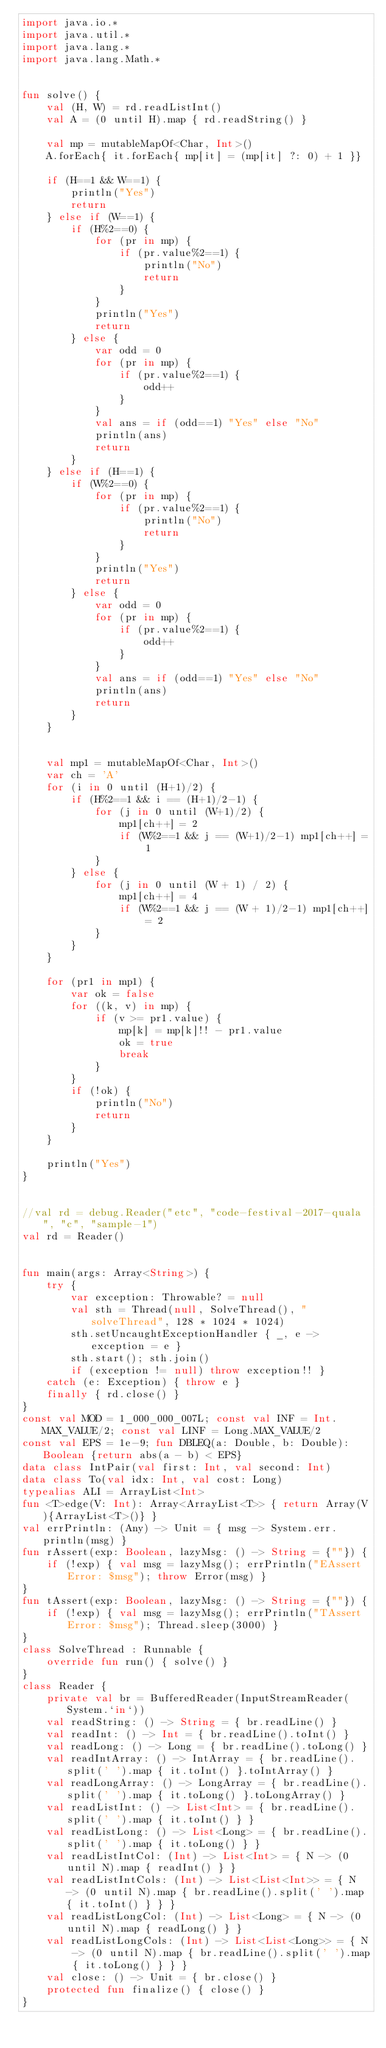<code> <loc_0><loc_0><loc_500><loc_500><_Kotlin_>import java.io.*
import java.util.*
import java.lang.*
import java.lang.Math.*


fun solve() {
    val (H, W) = rd.readListInt()
    val A = (0 until H).map { rd.readString() }

    val mp = mutableMapOf<Char, Int>()
    A.forEach{ it.forEach{ mp[it] = (mp[it] ?: 0) + 1 }}

    if (H==1 && W==1) {
        println("Yes")
        return
    } else if (W==1) {
        if (H%2==0) {
            for (pr in mp) {
                if (pr.value%2==1) {
                    println("No")
                    return
                }
            }
            println("Yes")
            return
        } else {
            var odd = 0
            for (pr in mp) {
                if (pr.value%2==1) {
                    odd++
                }
            }
            val ans = if (odd==1) "Yes" else "No"
            println(ans)
            return
        }
    } else if (H==1) {
        if (W%2==0) {
            for (pr in mp) {
                if (pr.value%2==1) {
                    println("No")
                    return
                }
            }
            println("Yes")
            return
        } else {
            var odd = 0
            for (pr in mp) {
                if (pr.value%2==1) {
                    odd++
                }
            }
            val ans = if (odd==1) "Yes" else "No"
            println(ans)
            return
        }
    }


    val mp1 = mutableMapOf<Char, Int>()
    var ch = 'A'
    for (i in 0 until (H+1)/2) {
        if (H%2==1 && i == (H+1)/2-1) {
            for (j in 0 until (W+1)/2) {
                mp1[ch++] = 2
                if (W%2==1 && j == (W+1)/2-1) mp1[ch++] = 1
            }
        } else {
            for (j in 0 until (W + 1) / 2) {
                mp1[ch++] = 4
                if (W%2==1 && j == (W + 1)/2-1) mp1[ch++] = 2
            }
        }
    }

    for (pr1 in mp1) {
        var ok = false
        for ((k, v) in mp) {
            if (v >= pr1.value) {
                mp[k] = mp[k]!! - pr1.value
                ok = true
                break
            }
        }
        if (!ok) {
            println("No")
            return
        }
    }

    println("Yes")
}


//val rd = debug.Reader("etc", "code-festival-2017-quala", "c", "sample-1")
val rd = Reader()


fun main(args: Array<String>) {
    try {
        var exception: Throwable? = null
        val sth = Thread(null, SolveThread(), "solveThread", 128 * 1024 * 1024)
        sth.setUncaughtExceptionHandler { _, e -> exception = e }
        sth.start(); sth.join()
        if (exception != null) throw exception!! }
    catch (e: Exception) { throw e }
    finally { rd.close() }
}
const val MOD = 1_000_000_007L; const val INF = Int.MAX_VALUE/2; const val LINF = Long.MAX_VALUE/2
const val EPS = 1e-9; fun DBLEQ(a: Double, b: Double): Boolean {return abs(a - b) < EPS}
data class IntPair(val first: Int, val second: Int)
data class To(val idx: Int, val cost: Long)
typealias ALI = ArrayList<Int>
fun <T>edge(V: Int): Array<ArrayList<T>> { return Array(V){ArrayList<T>()} }
val errPrintln: (Any) -> Unit = { msg -> System.err.println(msg) }
fun rAssert(exp: Boolean, lazyMsg: () -> String = {""}) {
    if (!exp) { val msg = lazyMsg(); errPrintln("EAssert Error: $msg"); throw Error(msg) }
}
fun tAssert(exp: Boolean, lazyMsg: () -> String = {""}) {
    if (!exp) { val msg = lazyMsg(); errPrintln("TAssert Error: $msg"); Thread.sleep(3000) }
}
class SolveThread : Runnable {
    override fun run() { solve() }
}
class Reader {
    private val br = BufferedReader(InputStreamReader(System.`in`))
    val readString: () -> String = { br.readLine() }
    val readInt: () -> Int = { br.readLine().toInt() }
    val readLong: () -> Long = { br.readLine().toLong() }
    val readIntArray: () -> IntArray = { br.readLine().split(' ').map { it.toInt() }.toIntArray() }
    val readLongArray: () -> LongArray = { br.readLine().split(' ').map { it.toLong() }.toLongArray() }
    val readListInt: () -> List<Int> = { br.readLine().split(' ').map { it.toInt() } }
    val readListLong: () -> List<Long> = { br.readLine().split(' ').map { it.toLong() } }
    val readListIntCol: (Int) -> List<Int> = { N -> (0 until N).map { readInt() } }
    val readListIntCols: (Int) -> List<List<Int>> = { N -> (0 until N).map { br.readLine().split(' ').map { it.toInt() } } }
    val readListLongCol: (Int) -> List<Long> = { N -> (0 until N).map { readLong() } }
    val readListLongCols: (Int) -> List<List<Long>> = { N -> (0 until N).map { br.readLine().split(' ').map { it.toLong() } } }
    val close: () -> Unit = { br.close() }
    protected fun finalize() { close() }
}
</code> 